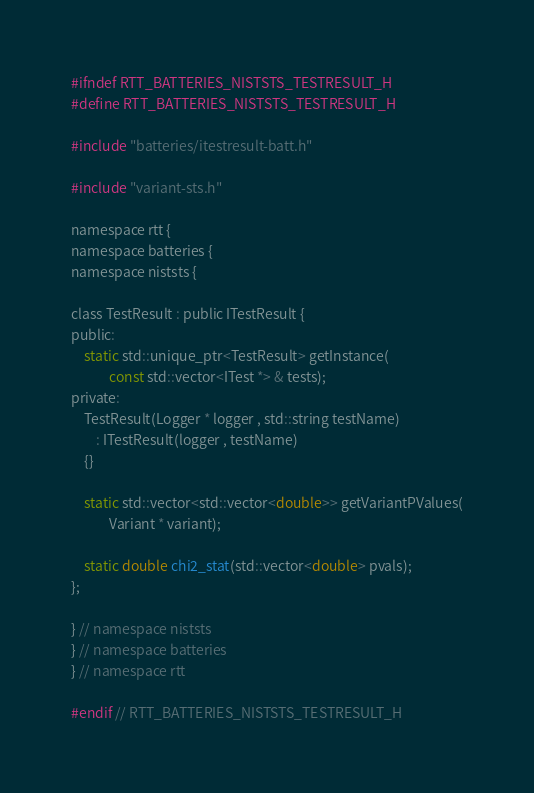Convert code to text. <code><loc_0><loc_0><loc_500><loc_500><_C_>#ifndef RTT_BATTERIES_NISTSTS_TESTRESULT_H
#define RTT_BATTERIES_NISTSTS_TESTRESULT_H

#include "batteries/itestresult-batt.h"

#include "variant-sts.h"

namespace rtt {
namespace batteries {
namespace niststs {

class TestResult : public ITestResult {
public:
    static std::unique_ptr<TestResult> getInstance(
            const std::vector<ITest *> & tests);
private:
    TestResult(Logger * logger , std::string testName)
        : ITestResult(logger , testName)
    {}

    static std::vector<std::vector<double>> getVariantPValues(
            Variant * variant);

    static double chi2_stat(std::vector<double> pvals);
};

} // namespace niststs
} // namespace batteries
} // namespace rtt

#endif // RTT_BATTERIES_NISTSTS_TESTRESULT_H
</code> 